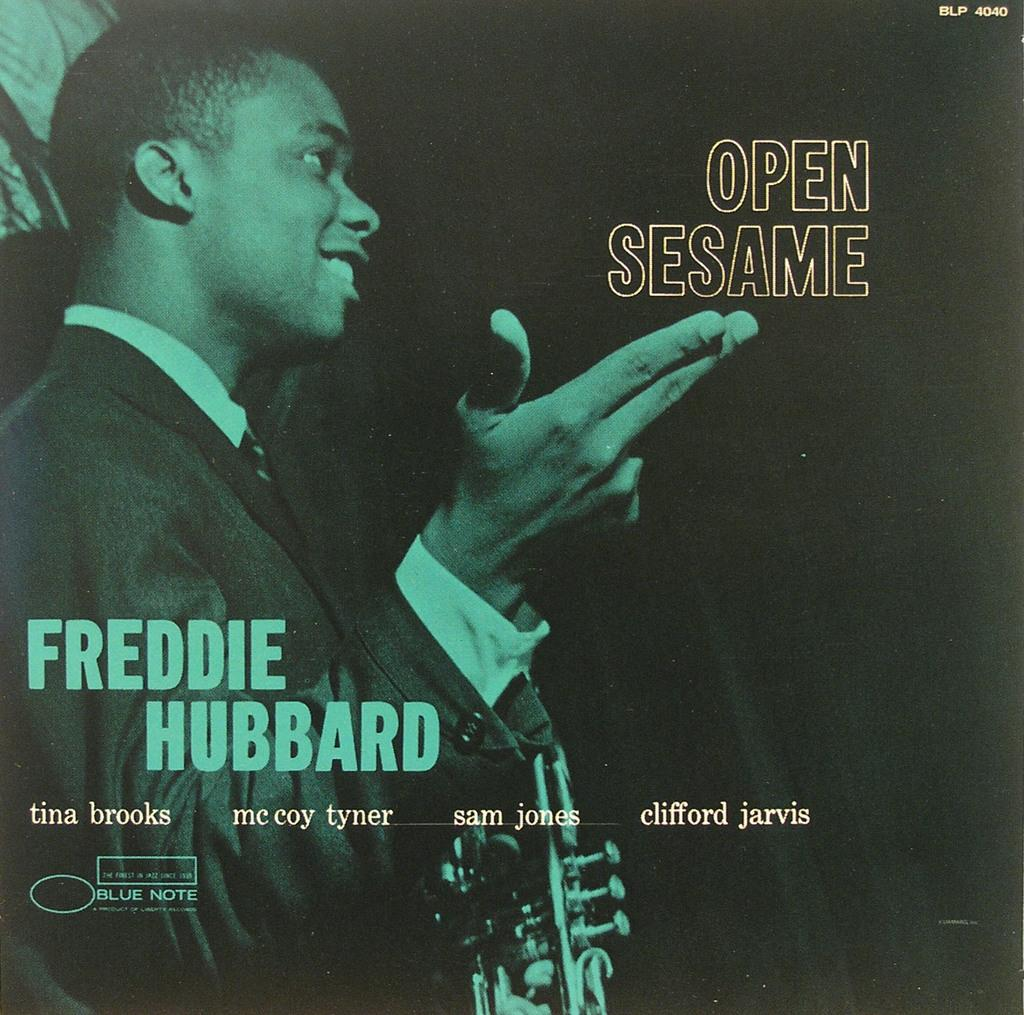Provide a one-sentence caption for the provided image. The name of the album is Open Sesame by Freddie Hubbard. 